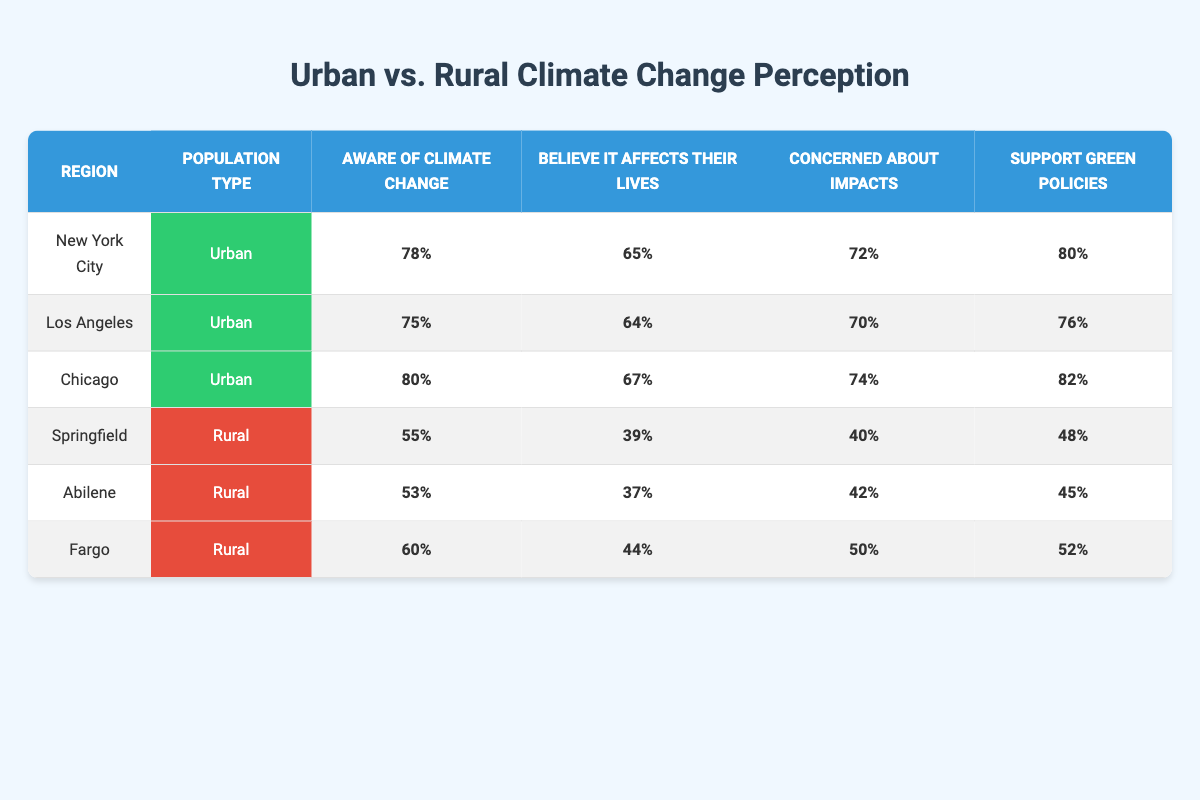What is the percentage of people in New York City who are aware of climate change? The table shows that in New York City, the percentage of people aware of climate change is specifically indicated in the row for that city, which states 78%.
Answer: 78% What percentage of the rural population in Springfield believes climate change affects their lives? The information for Springfield, which is categorized as rural, states that 39% of its population believes climate change affects their lives.
Answer: 39% Which city has the highest percentage of support for green policies among urban areas? By comparing the support for green policies across the urban cities listed, Chicago has the highest percentage at 82% as indicated in its row.
Answer: Chicago What is the average percentage of rural populations that are aware of climate change? To find this average, we take the percentages of awareness in the rural regions: Springfield (55%), Abilene (53%), and Fargo (60%). Adding these gives (55 + 53 + 60) = 168. We divide by the number of rural regions (3) which results in an average of 168/3 = 56%.
Answer: 56% Is it true that the percentage of urban dwellers who support green policies is higher than that of rural dwellers? Looking at the support for green policies, the highest percentage for rural areas is 52% (Fargo), while the urban areas have percentages of 76%, 80%, and 82%. Each urban area exceeds the highest rural percentage, confirming the statement is true.
Answer: Yes Which urban area has the lowest percentage of individuals believing that climate change affects their lives, and what is that percentage? From the urban areas listed, Los Angeles has the lowest percentage at 64%, as shown in its respective row, while other urban locations have higher values.
Answer: Los Angeles, 64% What is the difference in the percentage of urban populations concerned about the impacts of climate change between New York City and Los Angeles? To find the difference, we take the concerned percentages: New York City is 72% and Los Angeles is 70%. The difference is 72 - 70 = 2%.
Answer: 2% What percentage of the total rural population supports green policies based on the data provided? We calculate the support percentages for rural populations: Springfield (48%), Abilene (45%), and Fargo (52%). Adding these gives (48 + 45 + 52) = 145. We then find the average by dividing by 3, obtaining 145/3 = approximately 48.33%. Since it was asked for a firm percentage, we can report it based as 48%.
Answer: 48% 